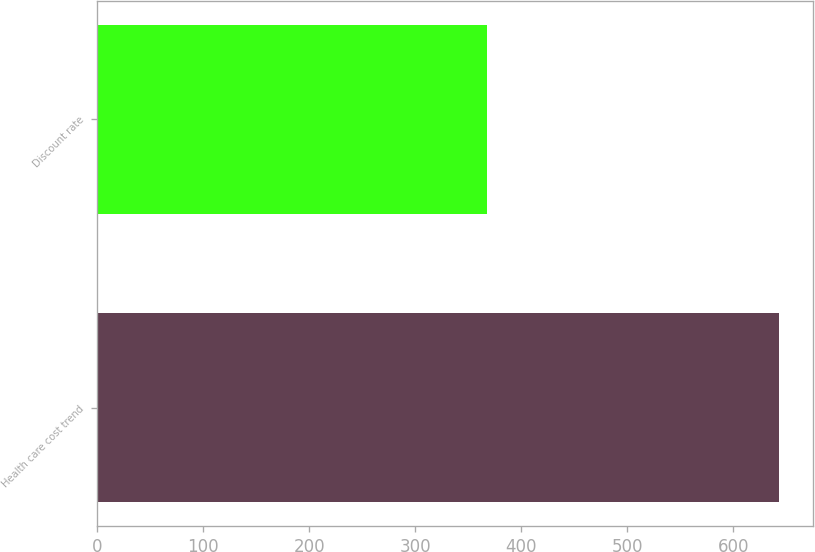Convert chart to OTSL. <chart><loc_0><loc_0><loc_500><loc_500><bar_chart><fcel>Health care cost trend<fcel>Discount rate<nl><fcel>643<fcel>368<nl></chart> 